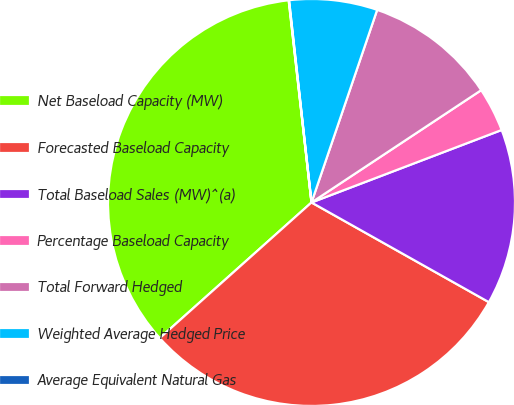Convert chart. <chart><loc_0><loc_0><loc_500><loc_500><pie_chart><fcel>Net Baseload Capacity (MW)<fcel>Forecasted Baseload Capacity<fcel>Total Baseload Sales (MW)^(a)<fcel>Percentage Baseload Capacity<fcel>Total Forward Hedged<fcel>Weighted Average Hedged Price<fcel>Average Equivalent Natural Gas<nl><fcel>34.83%<fcel>30.25%<fcel>13.95%<fcel>3.51%<fcel>10.47%<fcel>6.99%<fcel>0.03%<nl></chart> 